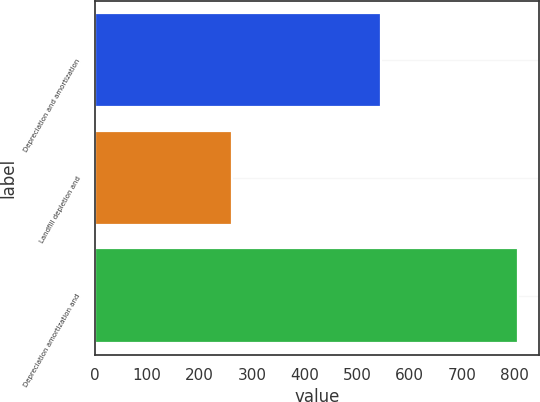<chart> <loc_0><loc_0><loc_500><loc_500><bar_chart><fcel>Depreciation and amortization<fcel>Landfill depletion and<fcel>Depreciation amortization and<nl><fcel>544.8<fcel>261.9<fcel>806.7<nl></chart> 